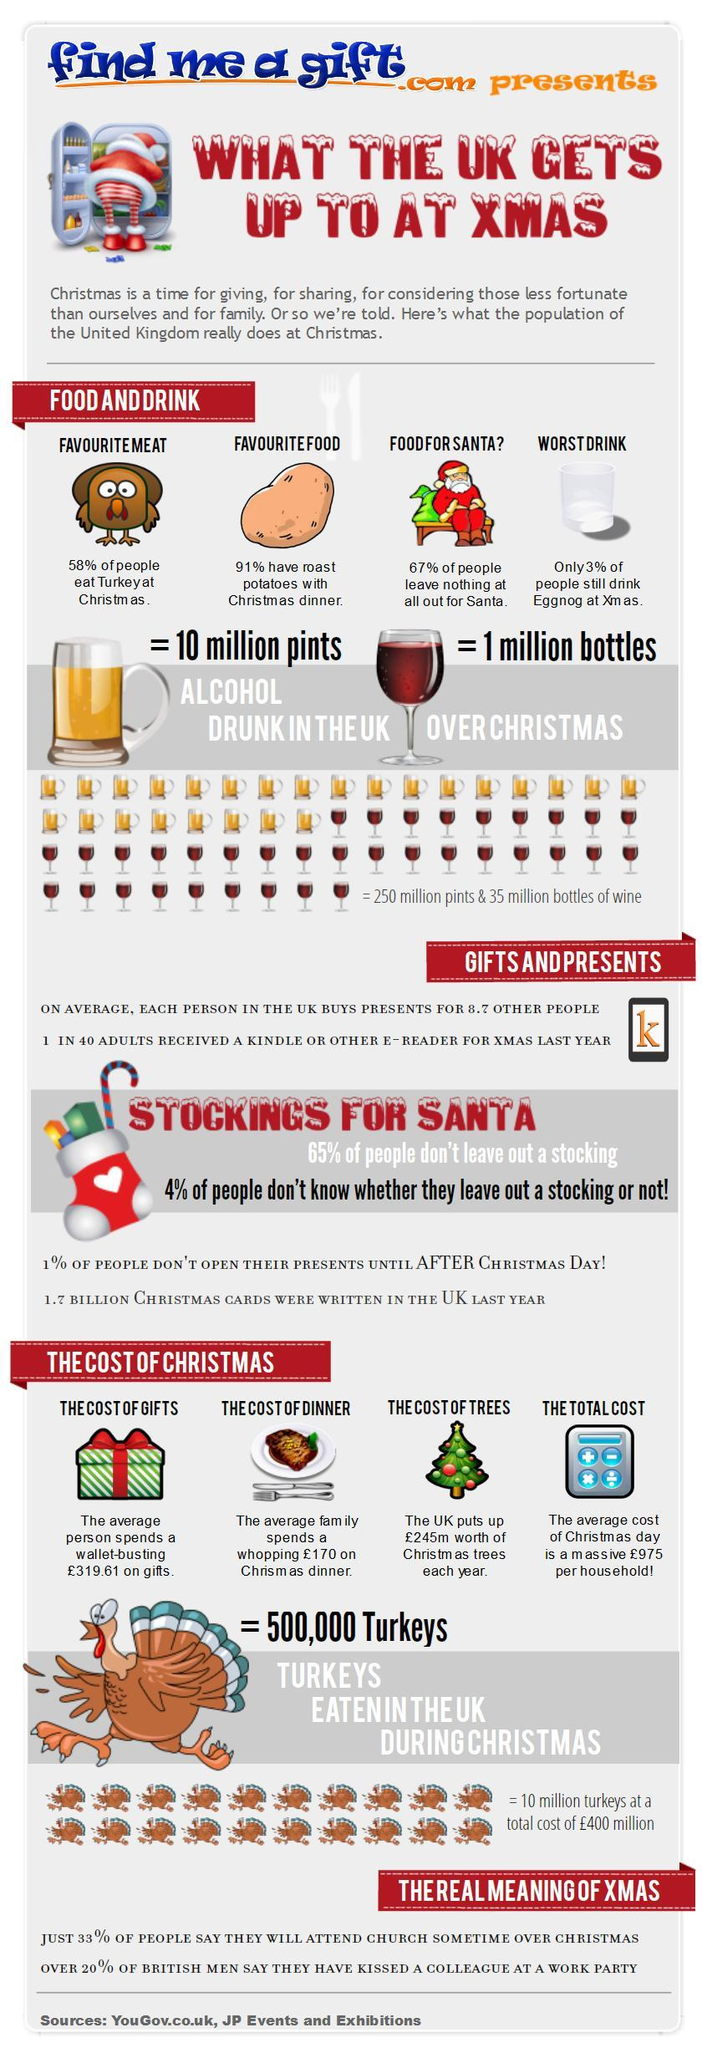What is the percentage of people who don't eat turkey at Christmas?
Answer the question with a short phrase. 42 What is the percentage of adults who got kindle or e-reader for last Christmas? 25 What is the percentage of people who don't drink eggnog at Christmas? 97 types of costs given under the topic "the cost of Christmas" in this infographics apart from the total cost of Christmas? the cost of gifts, the cost of dinner, the cost of trees What is the percentage of people who leave nothing out for Santa? 67% What is the percentage of people who don't have roast potatoes with Christmas dinner? 9% The number of vector images of glass of wine in this infographic is? 36 The number of vector images of turkey in this infographic is? 22 What color in which the text "find me a gift" is written - blue, black or red? blue number of Christmas trees given in this infographic is? 1 